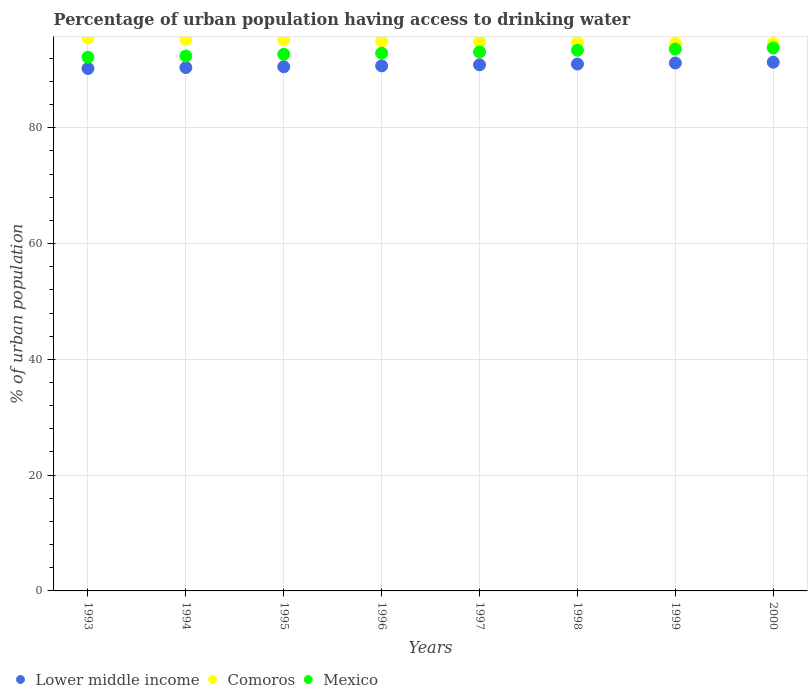How many different coloured dotlines are there?
Your response must be concise. 3. Is the number of dotlines equal to the number of legend labels?
Provide a succinct answer. Yes. What is the percentage of urban population having access to drinking water in Lower middle income in 1995?
Your answer should be very brief. 90.55. Across all years, what is the maximum percentage of urban population having access to drinking water in Lower middle income?
Your answer should be compact. 91.34. Across all years, what is the minimum percentage of urban population having access to drinking water in Lower middle income?
Provide a succinct answer. 90.26. In which year was the percentage of urban population having access to drinking water in Mexico maximum?
Provide a succinct answer. 2000. In which year was the percentage of urban population having access to drinking water in Comoros minimum?
Offer a very short reply. 2000. What is the total percentage of urban population having access to drinking water in Mexico in the graph?
Provide a short and direct response. 744.1. What is the difference between the percentage of urban population having access to drinking water in Comoros in 1993 and the percentage of urban population having access to drinking water in Lower middle income in 1994?
Offer a very short reply. 5.09. What is the average percentage of urban population having access to drinking water in Comoros per year?
Give a very brief answer. 94.97. In the year 2000, what is the difference between the percentage of urban population having access to drinking water in Comoros and percentage of urban population having access to drinking water in Mexico?
Provide a succinct answer. 0.7. In how many years, is the percentage of urban population having access to drinking water in Lower middle income greater than 68 %?
Make the answer very short. 8. What is the ratio of the percentage of urban population having access to drinking water in Lower middle income in 1994 to that in 2000?
Provide a short and direct response. 0.99. Is the percentage of urban population having access to drinking water in Comoros in 1994 less than that in 1998?
Your answer should be very brief. No. What is the difference between the highest and the second highest percentage of urban population having access to drinking water in Comoros?
Offer a very short reply. 0.2. What is the difference between the highest and the lowest percentage of urban population having access to drinking water in Lower middle income?
Offer a terse response. 1.08. In how many years, is the percentage of urban population having access to drinking water in Lower middle income greater than the average percentage of urban population having access to drinking water in Lower middle income taken over all years?
Provide a succinct answer. 4. Is it the case that in every year, the sum of the percentage of urban population having access to drinking water in Lower middle income and percentage of urban population having access to drinking water in Mexico  is greater than the percentage of urban population having access to drinking water in Comoros?
Keep it short and to the point. Yes. Does the percentage of urban population having access to drinking water in Mexico monotonically increase over the years?
Your answer should be very brief. Yes. Is the percentage of urban population having access to drinking water in Lower middle income strictly greater than the percentage of urban population having access to drinking water in Mexico over the years?
Your answer should be very brief. No. Is the percentage of urban population having access to drinking water in Mexico strictly less than the percentage of urban population having access to drinking water in Lower middle income over the years?
Offer a terse response. No. How many dotlines are there?
Provide a short and direct response. 3. What is the difference between two consecutive major ticks on the Y-axis?
Provide a succinct answer. 20. Does the graph contain any zero values?
Provide a succinct answer. No. Does the graph contain grids?
Your response must be concise. Yes. How many legend labels are there?
Ensure brevity in your answer.  3. How are the legend labels stacked?
Make the answer very short. Horizontal. What is the title of the graph?
Offer a very short reply. Percentage of urban population having access to drinking water. What is the label or title of the X-axis?
Provide a short and direct response. Years. What is the label or title of the Y-axis?
Provide a short and direct response. % of urban population. What is the % of urban population of Lower middle income in 1993?
Your response must be concise. 90.26. What is the % of urban population in Comoros in 1993?
Give a very brief answer. 95.5. What is the % of urban population of Mexico in 1993?
Offer a very short reply. 92.2. What is the % of urban population of Lower middle income in 1994?
Keep it short and to the point. 90.41. What is the % of urban population in Comoros in 1994?
Ensure brevity in your answer.  95.3. What is the % of urban population in Mexico in 1994?
Give a very brief answer. 92.4. What is the % of urban population of Lower middle income in 1995?
Your response must be concise. 90.55. What is the % of urban population of Comoros in 1995?
Offer a very short reply. 95.2. What is the % of urban population in Mexico in 1995?
Make the answer very short. 92.7. What is the % of urban population in Lower middle income in 1996?
Your response must be concise. 90.7. What is the % of urban population of Mexico in 1996?
Keep it short and to the point. 92.9. What is the % of urban population of Lower middle income in 1997?
Provide a succinct answer. 90.88. What is the % of urban population in Comoros in 1997?
Your answer should be compact. 94.9. What is the % of urban population in Mexico in 1997?
Offer a terse response. 93.1. What is the % of urban population of Lower middle income in 1998?
Provide a short and direct response. 91.02. What is the % of urban population in Comoros in 1998?
Provide a succinct answer. 94.8. What is the % of urban population of Mexico in 1998?
Ensure brevity in your answer.  93.4. What is the % of urban population in Lower middle income in 1999?
Your answer should be compact. 91.2. What is the % of urban population in Comoros in 1999?
Give a very brief answer. 94.6. What is the % of urban population in Mexico in 1999?
Offer a terse response. 93.6. What is the % of urban population of Lower middle income in 2000?
Give a very brief answer. 91.34. What is the % of urban population in Comoros in 2000?
Ensure brevity in your answer.  94.5. What is the % of urban population of Mexico in 2000?
Keep it short and to the point. 93.8. Across all years, what is the maximum % of urban population in Lower middle income?
Offer a terse response. 91.34. Across all years, what is the maximum % of urban population in Comoros?
Keep it short and to the point. 95.5. Across all years, what is the maximum % of urban population in Mexico?
Give a very brief answer. 93.8. Across all years, what is the minimum % of urban population in Lower middle income?
Make the answer very short. 90.26. Across all years, what is the minimum % of urban population of Comoros?
Provide a succinct answer. 94.5. Across all years, what is the minimum % of urban population in Mexico?
Provide a short and direct response. 92.2. What is the total % of urban population of Lower middle income in the graph?
Make the answer very short. 726.35. What is the total % of urban population in Comoros in the graph?
Keep it short and to the point. 759.8. What is the total % of urban population in Mexico in the graph?
Offer a terse response. 744.1. What is the difference between the % of urban population of Lower middle income in 1993 and that in 1994?
Offer a terse response. -0.16. What is the difference between the % of urban population of Comoros in 1993 and that in 1994?
Offer a very short reply. 0.2. What is the difference between the % of urban population in Lower middle income in 1993 and that in 1995?
Your answer should be very brief. -0.29. What is the difference between the % of urban population in Mexico in 1993 and that in 1995?
Make the answer very short. -0.5. What is the difference between the % of urban population in Lower middle income in 1993 and that in 1996?
Ensure brevity in your answer.  -0.45. What is the difference between the % of urban population of Lower middle income in 1993 and that in 1997?
Ensure brevity in your answer.  -0.63. What is the difference between the % of urban population of Mexico in 1993 and that in 1997?
Provide a short and direct response. -0.9. What is the difference between the % of urban population of Lower middle income in 1993 and that in 1998?
Offer a very short reply. -0.76. What is the difference between the % of urban population of Comoros in 1993 and that in 1998?
Your response must be concise. 0.7. What is the difference between the % of urban population in Mexico in 1993 and that in 1998?
Ensure brevity in your answer.  -1.2. What is the difference between the % of urban population in Lower middle income in 1993 and that in 1999?
Ensure brevity in your answer.  -0.95. What is the difference between the % of urban population in Lower middle income in 1993 and that in 2000?
Provide a succinct answer. -1.08. What is the difference between the % of urban population in Lower middle income in 1994 and that in 1995?
Ensure brevity in your answer.  -0.14. What is the difference between the % of urban population in Comoros in 1994 and that in 1995?
Your answer should be compact. 0.1. What is the difference between the % of urban population in Mexico in 1994 and that in 1995?
Offer a very short reply. -0.3. What is the difference between the % of urban population of Lower middle income in 1994 and that in 1996?
Offer a very short reply. -0.29. What is the difference between the % of urban population in Mexico in 1994 and that in 1996?
Ensure brevity in your answer.  -0.5. What is the difference between the % of urban population in Lower middle income in 1994 and that in 1997?
Provide a short and direct response. -0.47. What is the difference between the % of urban population of Mexico in 1994 and that in 1997?
Keep it short and to the point. -0.7. What is the difference between the % of urban population in Lower middle income in 1994 and that in 1998?
Ensure brevity in your answer.  -0.61. What is the difference between the % of urban population in Comoros in 1994 and that in 1998?
Your answer should be compact. 0.5. What is the difference between the % of urban population in Mexico in 1994 and that in 1998?
Keep it short and to the point. -1. What is the difference between the % of urban population in Lower middle income in 1994 and that in 1999?
Provide a succinct answer. -0.79. What is the difference between the % of urban population of Mexico in 1994 and that in 1999?
Give a very brief answer. -1.2. What is the difference between the % of urban population of Lower middle income in 1994 and that in 2000?
Provide a succinct answer. -0.93. What is the difference between the % of urban population of Mexico in 1994 and that in 2000?
Your response must be concise. -1.4. What is the difference between the % of urban population in Lower middle income in 1995 and that in 1996?
Your answer should be compact. -0.16. What is the difference between the % of urban population in Mexico in 1995 and that in 1996?
Keep it short and to the point. -0.2. What is the difference between the % of urban population of Lower middle income in 1995 and that in 1997?
Offer a terse response. -0.34. What is the difference between the % of urban population of Comoros in 1995 and that in 1997?
Offer a very short reply. 0.3. What is the difference between the % of urban population in Mexico in 1995 and that in 1997?
Your answer should be very brief. -0.4. What is the difference between the % of urban population in Lower middle income in 1995 and that in 1998?
Give a very brief answer. -0.47. What is the difference between the % of urban population of Comoros in 1995 and that in 1998?
Ensure brevity in your answer.  0.4. What is the difference between the % of urban population in Lower middle income in 1995 and that in 1999?
Keep it short and to the point. -0.65. What is the difference between the % of urban population in Mexico in 1995 and that in 1999?
Provide a succinct answer. -0.9. What is the difference between the % of urban population of Lower middle income in 1995 and that in 2000?
Keep it short and to the point. -0.79. What is the difference between the % of urban population of Mexico in 1995 and that in 2000?
Your response must be concise. -1.1. What is the difference between the % of urban population of Lower middle income in 1996 and that in 1997?
Make the answer very short. -0.18. What is the difference between the % of urban population in Comoros in 1996 and that in 1997?
Your answer should be compact. 0.1. What is the difference between the % of urban population in Lower middle income in 1996 and that in 1998?
Offer a very short reply. -0.31. What is the difference between the % of urban population in Comoros in 1996 and that in 1998?
Offer a terse response. 0.2. What is the difference between the % of urban population in Mexico in 1996 and that in 1998?
Offer a terse response. -0.5. What is the difference between the % of urban population of Lower middle income in 1996 and that in 1999?
Offer a very short reply. -0.5. What is the difference between the % of urban population of Comoros in 1996 and that in 1999?
Your answer should be compact. 0.4. What is the difference between the % of urban population of Lower middle income in 1996 and that in 2000?
Offer a terse response. -0.63. What is the difference between the % of urban population of Mexico in 1996 and that in 2000?
Offer a terse response. -0.9. What is the difference between the % of urban population of Lower middle income in 1997 and that in 1998?
Your answer should be very brief. -0.13. What is the difference between the % of urban population in Mexico in 1997 and that in 1998?
Make the answer very short. -0.3. What is the difference between the % of urban population of Lower middle income in 1997 and that in 1999?
Make the answer very short. -0.32. What is the difference between the % of urban population of Comoros in 1997 and that in 1999?
Keep it short and to the point. 0.3. What is the difference between the % of urban population of Lower middle income in 1997 and that in 2000?
Offer a terse response. -0.45. What is the difference between the % of urban population in Comoros in 1997 and that in 2000?
Offer a very short reply. 0.4. What is the difference between the % of urban population in Lower middle income in 1998 and that in 1999?
Give a very brief answer. -0.18. What is the difference between the % of urban population in Mexico in 1998 and that in 1999?
Keep it short and to the point. -0.2. What is the difference between the % of urban population of Lower middle income in 1998 and that in 2000?
Your answer should be very brief. -0.32. What is the difference between the % of urban population of Lower middle income in 1999 and that in 2000?
Ensure brevity in your answer.  -0.14. What is the difference between the % of urban population in Comoros in 1999 and that in 2000?
Your response must be concise. 0.1. What is the difference between the % of urban population in Lower middle income in 1993 and the % of urban population in Comoros in 1994?
Provide a short and direct response. -5.04. What is the difference between the % of urban population of Lower middle income in 1993 and the % of urban population of Mexico in 1994?
Provide a short and direct response. -2.14. What is the difference between the % of urban population of Lower middle income in 1993 and the % of urban population of Comoros in 1995?
Offer a very short reply. -4.94. What is the difference between the % of urban population of Lower middle income in 1993 and the % of urban population of Mexico in 1995?
Offer a terse response. -2.44. What is the difference between the % of urban population of Comoros in 1993 and the % of urban population of Mexico in 1995?
Make the answer very short. 2.8. What is the difference between the % of urban population of Lower middle income in 1993 and the % of urban population of Comoros in 1996?
Keep it short and to the point. -4.74. What is the difference between the % of urban population in Lower middle income in 1993 and the % of urban population in Mexico in 1996?
Your answer should be very brief. -2.64. What is the difference between the % of urban population in Comoros in 1993 and the % of urban population in Mexico in 1996?
Give a very brief answer. 2.6. What is the difference between the % of urban population in Lower middle income in 1993 and the % of urban population in Comoros in 1997?
Offer a very short reply. -4.64. What is the difference between the % of urban population in Lower middle income in 1993 and the % of urban population in Mexico in 1997?
Make the answer very short. -2.84. What is the difference between the % of urban population of Comoros in 1993 and the % of urban population of Mexico in 1997?
Offer a terse response. 2.4. What is the difference between the % of urban population of Lower middle income in 1993 and the % of urban population of Comoros in 1998?
Your answer should be very brief. -4.54. What is the difference between the % of urban population in Lower middle income in 1993 and the % of urban population in Mexico in 1998?
Give a very brief answer. -3.14. What is the difference between the % of urban population of Lower middle income in 1993 and the % of urban population of Comoros in 1999?
Give a very brief answer. -4.34. What is the difference between the % of urban population of Lower middle income in 1993 and the % of urban population of Mexico in 1999?
Give a very brief answer. -3.34. What is the difference between the % of urban population of Comoros in 1993 and the % of urban population of Mexico in 1999?
Your answer should be very brief. 1.9. What is the difference between the % of urban population of Lower middle income in 1993 and the % of urban population of Comoros in 2000?
Give a very brief answer. -4.24. What is the difference between the % of urban population in Lower middle income in 1993 and the % of urban population in Mexico in 2000?
Your answer should be very brief. -3.54. What is the difference between the % of urban population of Lower middle income in 1994 and the % of urban population of Comoros in 1995?
Keep it short and to the point. -4.79. What is the difference between the % of urban population in Lower middle income in 1994 and the % of urban population in Mexico in 1995?
Offer a very short reply. -2.29. What is the difference between the % of urban population in Comoros in 1994 and the % of urban population in Mexico in 1995?
Offer a terse response. 2.6. What is the difference between the % of urban population of Lower middle income in 1994 and the % of urban population of Comoros in 1996?
Make the answer very short. -4.59. What is the difference between the % of urban population of Lower middle income in 1994 and the % of urban population of Mexico in 1996?
Offer a terse response. -2.49. What is the difference between the % of urban population of Comoros in 1994 and the % of urban population of Mexico in 1996?
Your response must be concise. 2.4. What is the difference between the % of urban population of Lower middle income in 1994 and the % of urban population of Comoros in 1997?
Give a very brief answer. -4.49. What is the difference between the % of urban population of Lower middle income in 1994 and the % of urban population of Mexico in 1997?
Your response must be concise. -2.69. What is the difference between the % of urban population of Lower middle income in 1994 and the % of urban population of Comoros in 1998?
Your answer should be compact. -4.39. What is the difference between the % of urban population in Lower middle income in 1994 and the % of urban population in Mexico in 1998?
Offer a terse response. -2.99. What is the difference between the % of urban population in Comoros in 1994 and the % of urban population in Mexico in 1998?
Give a very brief answer. 1.9. What is the difference between the % of urban population of Lower middle income in 1994 and the % of urban population of Comoros in 1999?
Provide a short and direct response. -4.19. What is the difference between the % of urban population in Lower middle income in 1994 and the % of urban population in Mexico in 1999?
Provide a succinct answer. -3.19. What is the difference between the % of urban population in Lower middle income in 1994 and the % of urban population in Comoros in 2000?
Your response must be concise. -4.09. What is the difference between the % of urban population in Lower middle income in 1994 and the % of urban population in Mexico in 2000?
Offer a very short reply. -3.39. What is the difference between the % of urban population in Comoros in 1994 and the % of urban population in Mexico in 2000?
Your answer should be compact. 1.5. What is the difference between the % of urban population of Lower middle income in 1995 and the % of urban population of Comoros in 1996?
Make the answer very short. -4.45. What is the difference between the % of urban population in Lower middle income in 1995 and the % of urban population in Mexico in 1996?
Ensure brevity in your answer.  -2.35. What is the difference between the % of urban population in Lower middle income in 1995 and the % of urban population in Comoros in 1997?
Your response must be concise. -4.35. What is the difference between the % of urban population of Lower middle income in 1995 and the % of urban population of Mexico in 1997?
Your answer should be compact. -2.55. What is the difference between the % of urban population of Lower middle income in 1995 and the % of urban population of Comoros in 1998?
Ensure brevity in your answer.  -4.25. What is the difference between the % of urban population of Lower middle income in 1995 and the % of urban population of Mexico in 1998?
Make the answer very short. -2.85. What is the difference between the % of urban population in Lower middle income in 1995 and the % of urban population in Comoros in 1999?
Offer a very short reply. -4.05. What is the difference between the % of urban population of Lower middle income in 1995 and the % of urban population of Mexico in 1999?
Offer a very short reply. -3.05. What is the difference between the % of urban population of Comoros in 1995 and the % of urban population of Mexico in 1999?
Ensure brevity in your answer.  1.6. What is the difference between the % of urban population in Lower middle income in 1995 and the % of urban population in Comoros in 2000?
Provide a succinct answer. -3.95. What is the difference between the % of urban population in Lower middle income in 1995 and the % of urban population in Mexico in 2000?
Ensure brevity in your answer.  -3.25. What is the difference between the % of urban population of Comoros in 1995 and the % of urban population of Mexico in 2000?
Your answer should be compact. 1.4. What is the difference between the % of urban population in Lower middle income in 1996 and the % of urban population in Comoros in 1997?
Keep it short and to the point. -4.2. What is the difference between the % of urban population in Lower middle income in 1996 and the % of urban population in Mexico in 1997?
Provide a short and direct response. -2.4. What is the difference between the % of urban population of Comoros in 1996 and the % of urban population of Mexico in 1997?
Make the answer very short. 1.9. What is the difference between the % of urban population of Lower middle income in 1996 and the % of urban population of Comoros in 1998?
Your answer should be very brief. -4.1. What is the difference between the % of urban population in Lower middle income in 1996 and the % of urban population in Mexico in 1998?
Your answer should be very brief. -2.7. What is the difference between the % of urban population in Lower middle income in 1996 and the % of urban population in Comoros in 1999?
Offer a terse response. -3.9. What is the difference between the % of urban population in Lower middle income in 1996 and the % of urban population in Mexico in 1999?
Provide a succinct answer. -2.9. What is the difference between the % of urban population of Lower middle income in 1996 and the % of urban population of Comoros in 2000?
Offer a very short reply. -3.8. What is the difference between the % of urban population of Lower middle income in 1996 and the % of urban population of Mexico in 2000?
Provide a short and direct response. -3.1. What is the difference between the % of urban population of Comoros in 1996 and the % of urban population of Mexico in 2000?
Provide a short and direct response. 1.2. What is the difference between the % of urban population in Lower middle income in 1997 and the % of urban population in Comoros in 1998?
Provide a short and direct response. -3.92. What is the difference between the % of urban population in Lower middle income in 1997 and the % of urban population in Mexico in 1998?
Offer a very short reply. -2.52. What is the difference between the % of urban population of Comoros in 1997 and the % of urban population of Mexico in 1998?
Provide a short and direct response. 1.5. What is the difference between the % of urban population of Lower middle income in 1997 and the % of urban population of Comoros in 1999?
Your answer should be very brief. -3.72. What is the difference between the % of urban population of Lower middle income in 1997 and the % of urban population of Mexico in 1999?
Provide a succinct answer. -2.72. What is the difference between the % of urban population of Comoros in 1997 and the % of urban population of Mexico in 1999?
Offer a very short reply. 1.3. What is the difference between the % of urban population in Lower middle income in 1997 and the % of urban population in Comoros in 2000?
Make the answer very short. -3.62. What is the difference between the % of urban population of Lower middle income in 1997 and the % of urban population of Mexico in 2000?
Make the answer very short. -2.92. What is the difference between the % of urban population of Lower middle income in 1998 and the % of urban population of Comoros in 1999?
Your answer should be very brief. -3.58. What is the difference between the % of urban population in Lower middle income in 1998 and the % of urban population in Mexico in 1999?
Give a very brief answer. -2.58. What is the difference between the % of urban population of Lower middle income in 1998 and the % of urban population of Comoros in 2000?
Offer a very short reply. -3.48. What is the difference between the % of urban population in Lower middle income in 1998 and the % of urban population in Mexico in 2000?
Your response must be concise. -2.78. What is the difference between the % of urban population of Lower middle income in 1999 and the % of urban population of Comoros in 2000?
Your response must be concise. -3.3. What is the difference between the % of urban population in Lower middle income in 1999 and the % of urban population in Mexico in 2000?
Offer a very short reply. -2.6. What is the difference between the % of urban population of Comoros in 1999 and the % of urban population of Mexico in 2000?
Keep it short and to the point. 0.8. What is the average % of urban population of Lower middle income per year?
Offer a terse response. 90.79. What is the average % of urban population in Comoros per year?
Offer a terse response. 94.97. What is the average % of urban population of Mexico per year?
Your answer should be compact. 93.01. In the year 1993, what is the difference between the % of urban population of Lower middle income and % of urban population of Comoros?
Your response must be concise. -5.24. In the year 1993, what is the difference between the % of urban population in Lower middle income and % of urban population in Mexico?
Give a very brief answer. -1.94. In the year 1994, what is the difference between the % of urban population in Lower middle income and % of urban population in Comoros?
Provide a short and direct response. -4.89. In the year 1994, what is the difference between the % of urban population of Lower middle income and % of urban population of Mexico?
Your answer should be compact. -1.99. In the year 1995, what is the difference between the % of urban population of Lower middle income and % of urban population of Comoros?
Provide a succinct answer. -4.65. In the year 1995, what is the difference between the % of urban population of Lower middle income and % of urban population of Mexico?
Give a very brief answer. -2.15. In the year 1996, what is the difference between the % of urban population of Lower middle income and % of urban population of Comoros?
Offer a very short reply. -4.3. In the year 1996, what is the difference between the % of urban population in Lower middle income and % of urban population in Mexico?
Keep it short and to the point. -2.2. In the year 1996, what is the difference between the % of urban population in Comoros and % of urban population in Mexico?
Your response must be concise. 2.1. In the year 1997, what is the difference between the % of urban population of Lower middle income and % of urban population of Comoros?
Your answer should be compact. -4.02. In the year 1997, what is the difference between the % of urban population of Lower middle income and % of urban population of Mexico?
Provide a succinct answer. -2.22. In the year 1998, what is the difference between the % of urban population in Lower middle income and % of urban population in Comoros?
Provide a succinct answer. -3.78. In the year 1998, what is the difference between the % of urban population in Lower middle income and % of urban population in Mexico?
Provide a short and direct response. -2.38. In the year 1999, what is the difference between the % of urban population of Lower middle income and % of urban population of Comoros?
Keep it short and to the point. -3.4. In the year 1999, what is the difference between the % of urban population in Lower middle income and % of urban population in Mexico?
Give a very brief answer. -2.4. In the year 1999, what is the difference between the % of urban population of Comoros and % of urban population of Mexico?
Keep it short and to the point. 1. In the year 2000, what is the difference between the % of urban population of Lower middle income and % of urban population of Comoros?
Offer a terse response. -3.16. In the year 2000, what is the difference between the % of urban population in Lower middle income and % of urban population in Mexico?
Your answer should be very brief. -2.46. In the year 2000, what is the difference between the % of urban population of Comoros and % of urban population of Mexico?
Keep it short and to the point. 0.7. What is the ratio of the % of urban population of Comoros in 1993 to that in 1994?
Provide a short and direct response. 1. What is the ratio of the % of urban population of Lower middle income in 1993 to that in 1995?
Give a very brief answer. 1. What is the ratio of the % of urban population in Comoros in 1993 to that in 1995?
Your answer should be very brief. 1. What is the ratio of the % of urban population in Mexico in 1993 to that in 1995?
Your response must be concise. 0.99. What is the ratio of the % of urban population in Comoros in 1993 to that in 1996?
Offer a terse response. 1.01. What is the ratio of the % of urban population of Mexico in 1993 to that in 1996?
Provide a short and direct response. 0.99. What is the ratio of the % of urban population of Lower middle income in 1993 to that in 1997?
Your answer should be compact. 0.99. What is the ratio of the % of urban population of Mexico in 1993 to that in 1997?
Provide a succinct answer. 0.99. What is the ratio of the % of urban population of Comoros in 1993 to that in 1998?
Make the answer very short. 1.01. What is the ratio of the % of urban population in Mexico in 1993 to that in 1998?
Offer a terse response. 0.99. What is the ratio of the % of urban population of Comoros in 1993 to that in 1999?
Ensure brevity in your answer.  1.01. What is the ratio of the % of urban population in Mexico in 1993 to that in 1999?
Make the answer very short. 0.98. What is the ratio of the % of urban population in Comoros in 1993 to that in 2000?
Your response must be concise. 1.01. What is the ratio of the % of urban population in Mexico in 1993 to that in 2000?
Your answer should be very brief. 0.98. What is the ratio of the % of urban population in Lower middle income in 1994 to that in 1995?
Ensure brevity in your answer.  1. What is the ratio of the % of urban population of Comoros in 1994 to that in 1995?
Your response must be concise. 1. What is the ratio of the % of urban population of Comoros in 1994 to that in 1996?
Keep it short and to the point. 1. What is the ratio of the % of urban population in Comoros in 1994 to that in 1997?
Your answer should be compact. 1. What is the ratio of the % of urban population of Mexico in 1994 to that in 1997?
Offer a very short reply. 0.99. What is the ratio of the % of urban population in Lower middle income in 1994 to that in 1998?
Your response must be concise. 0.99. What is the ratio of the % of urban population in Comoros in 1994 to that in 1998?
Your answer should be very brief. 1.01. What is the ratio of the % of urban population of Mexico in 1994 to that in 1998?
Make the answer very short. 0.99. What is the ratio of the % of urban population of Lower middle income in 1994 to that in 1999?
Provide a succinct answer. 0.99. What is the ratio of the % of urban population in Comoros in 1994 to that in 1999?
Your answer should be compact. 1.01. What is the ratio of the % of urban population in Mexico in 1994 to that in 1999?
Offer a very short reply. 0.99. What is the ratio of the % of urban population in Comoros in 1994 to that in 2000?
Provide a short and direct response. 1.01. What is the ratio of the % of urban population of Mexico in 1994 to that in 2000?
Provide a succinct answer. 0.99. What is the ratio of the % of urban population of Mexico in 1995 to that in 1996?
Offer a terse response. 1. What is the ratio of the % of urban population of Lower middle income in 1995 to that in 1997?
Offer a terse response. 1. What is the ratio of the % of urban population of Comoros in 1995 to that in 1997?
Your answer should be very brief. 1. What is the ratio of the % of urban population in Mexico in 1995 to that in 1997?
Offer a very short reply. 1. What is the ratio of the % of urban population of Lower middle income in 1995 to that in 1998?
Offer a very short reply. 0.99. What is the ratio of the % of urban population in Comoros in 1995 to that in 1998?
Provide a succinct answer. 1. What is the ratio of the % of urban population of Mexico in 1995 to that in 1998?
Your answer should be very brief. 0.99. What is the ratio of the % of urban population in Lower middle income in 1995 to that in 1999?
Your response must be concise. 0.99. What is the ratio of the % of urban population in Mexico in 1995 to that in 1999?
Your response must be concise. 0.99. What is the ratio of the % of urban population in Comoros in 1995 to that in 2000?
Offer a very short reply. 1.01. What is the ratio of the % of urban population in Mexico in 1995 to that in 2000?
Ensure brevity in your answer.  0.99. What is the ratio of the % of urban population of Lower middle income in 1996 to that in 1997?
Provide a short and direct response. 1. What is the ratio of the % of urban population in Mexico in 1996 to that in 1997?
Give a very brief answer. 1. What is the ratio of the % of urban population in Comoros in 1996 to that in 1998?
Make the answer very short. 1. What is the ratio of the % of urban population in Mexico in 1996 to that in 1998?
Your answer should be very brief. 0.99. What is the ratio of the % of urban population in Lower middle income in 1996 to that in 1999?
Your answer should be compact. 0.99. What is the ratio of the % of urban population of Comoros in 1996 to that in 1999?
Give a very brief answer. 1. What is the ratio of the % of urban population in Comoros in 1996 to that in 2000?
Provide a short and direct response. 1.01. What is the ratio of the % of urban population in Lower middle income in 1997 to that in 1998?
Your answer should be compact. 1. What is the ratio of the % of urban population of Comoros in 1997 to that in 1998?
Offer a terse response. 1. What is the ratio of the % of urban population of Mexico in 1997 to that in 1998?
Your response must be concise. 1. What is the ratio of the % of urban population in Lower middle income in 1997 to that in 1999?
Give a very brief answer. 1. What is the ratio of the % of urban population in Comoros in 1997 to that in 1999?
Your response must be concise. 1. What is the ratio of the % of urban population of Mexico in 1997 to that in 1999?
Your response must be concise. 0.99. What is the ratio of the % of urban population in Lower middle income in 1997 to that in 2000?
Provide a short and direct response. 0.99. What is the ratio of the % of urban population of Comoros in 1997 to that in 2000?
Give a very brief answer. 1. What is the ratio of the % of urban population of Lower middle income in 1998 to that in 1999?
Keep it short and to the point. 1. What is the ratio of the % of urban population of Comoros in 1998 to that in 1999?
Your answer should be very brief. 1. What is the ratio of the % of urban population in Mexico in 1998 to that in 1999?
Your answer should be very brief. 1. What is the ratio of the % of urban population in Comoros in 1998 to that in 2000?
Ensure brevity in your answer.  1. What is the ratio of the % of urban population of Mexico in 1998 to that in 2000?
Make the answer very short. 1. What is the ratio of the % of urban population of Mexico in 1999 to that in 2000?
Your response must be concise. 1. What is the difference between the highest and the second highest % of urban population in Lower middle income?
Offer a very short reply. 0.14. What is the difference between the highest and the lowest % of urban population in Lower middle income?
Offer a terse response. 1.08. 